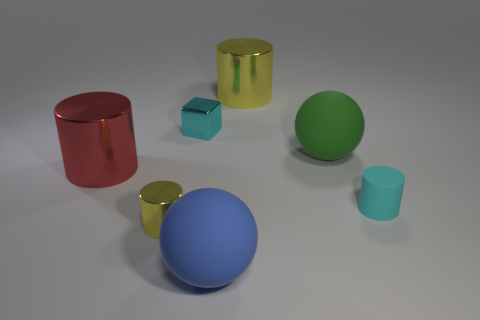There is a small block that is the same color as the rubber cylinder; what is its material?
Give a very brief answer. Metal. What number of things are cyan things to the left of the tiny cyan rubber object or cyan matte cylinders that are right of the green sphere?
Keep it short and to the point. 2. How many large shiny cylinders are to the left of the small yellow metal object that is behind the blue rubber sphere?
Provide a succinct answer. 1. The small cylinder that is the same material as the large yellow cylinder is what color?
Your response must be concise. Yellow. Are there any cylinders that have the same size as the green matte ball?
Offer a very short reply. Yes. There is a blue matte object that is the same size as the green ball; what shape is it?
Provide a short and direct response. Sphere. Are there any other small matte objects that have the same shape as the red object?
Give a very brief answer. Yes. Does the cube have the same material as the yellow cylinder to the left of the blue ball?
Offer a very short reply. Yes. Is there a tiny rubber cylinder of the same color as the small metal block?
Ensure brevity in your answer.  Yes. How many other things are the same material as the red cylinder?
Give a very brief answer. 3. 